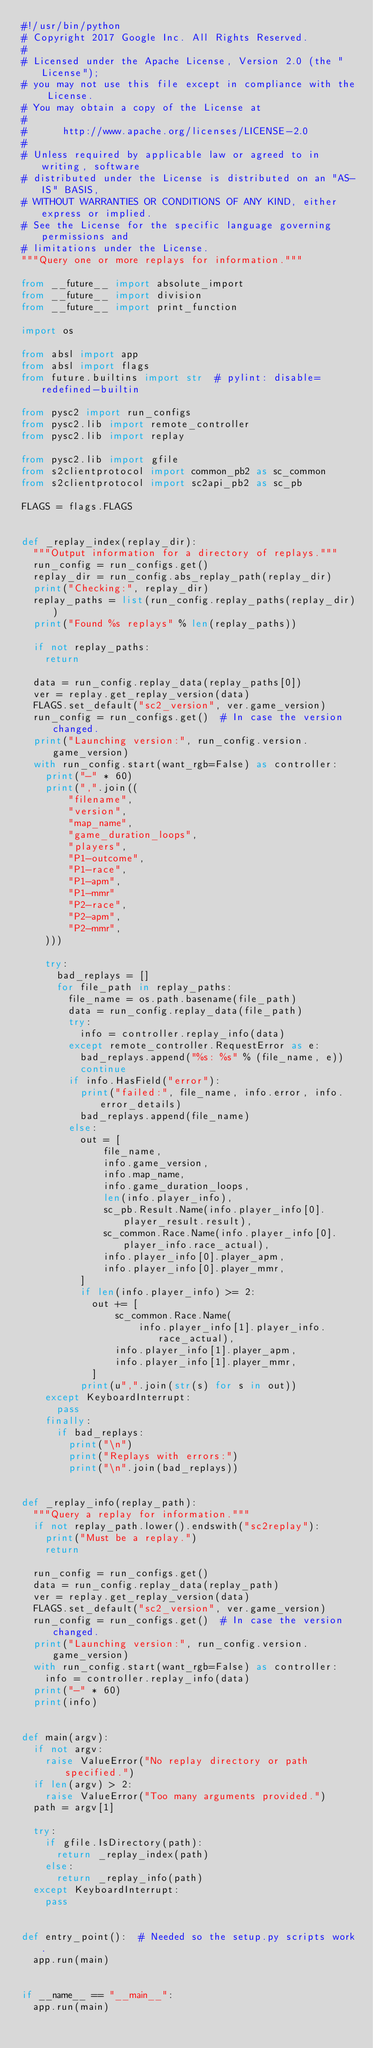<code> <loc_0><loc_0><loc_500><loc_500><_Python_>#!/usr/bin/python
# Copyright 2017 Google Inc. All Rights Reserved.
#
# Licensed under the Apache License, Version 2.0 (the "License");
# you may not use this file except in compliance with the License.
# You may obtain a copy of the License at
#
#      http://www.apache.org/licenses/LICENSE-2.0
#
# Unless required by applicable law or agreed to in writing, software
# distributed under the License is distributed on an "AS-IS" BASIS,
# WITHOUT WARRANTIES OR CONDITIONS OF ANY KIND, either express or implied.
# See the License for the specific language governing permissions and
# limitations under the License.
"""Query one or more replays for information."""

from __future__ import absolute_import
from __future__ import division
from __future__ import print_function

import os

from absl import app
from absl import flags
from future.builtins import str  # pylint: disable=redefined-builtin

from pysc2 import run_configs
from pysc2.lib import remote_controller
from pysc2.lib import replay

from pysc2.lib import gfile
from s2clientprotocol import common_pb2 as sc_common
from s2clientprotocol import sc2api_pb2 as sc_pb

FLAGS = flags.FLAGS


def _replay_index(replay_dir):
  """Output information for a directory of replays."""
  run_config = run_configs.get()
  replay_dir = run_config.abs_replay_path(replay_dir)
  print("Checking:", replay_dir)
  replay_paths = list(run_config.replay_paths(replay_dir))
  print("Found %s replays" % len(replay_paths))

  if not replay_paths:
    return

  data = run_config.replay_data(replay_paths[0])
  ver = replay.get_replay_version(data)
  FLAGS.set_default("sc2_version", ver.game_version)
  run_config = run_configs.get()  # In case the version changed.
  print("Launching version:", run_config.version.game_version)
  with run_config.start(want_rgb=False) as controller:
    print("-" * 60)
    print(",".join((
        "filename",
        "version",
        "map_name",
        "game_duration_loops",
        "players",
        "P1-outcome",
        "P1-race",
        "P1-apm",
        "P1-mmr"
        "P2-race",
        "P2-apm",
        "P2-mmr",
    )))

    try:
      bad_replays = []
      for file_path in replay_paths:
        file_name = os.path.basename(file_path)
        data = run_config.replay_data(file_path)
        try:
          info = controller.replay_info(data)
        except remote_controller.RequestError as e:
          bad_replays.append("%s: %s" % (file_name, e))
          continue
        if info.HasField("error"):
          print("failed:", file_name, info.error, info.error_details)
          bad_replays.append(file_name)
        else:
          out = [
              file_name,
              info.game_version,
              info.map_name,
              info.game_duration_loops,
              len(info.player_info),
              sc_pb.Result.Name(info.player_info[0].player_result.result),
              sc_common.Race.Name(info.player_info[0].player_info.race_actual),
              info.player_info[0].player_apm,
              info.player_info[0].player_mmr,
          ]
          if len(info.player_info) >= 2:
            out += [
                sc_common.Race.Name(
                    info.player_info[1].player_info.race_actual),
                info.player_info[1].player_apm,
                info.player_info[1].player_mmr,
            ]
          print(u",".join(str(s) for s in out))
    except KeyboardInterrupt:
      pass
    finally:
      if bad_replays:
        print("\n")
        print("Replays with errors:")
        print("\n".join(bad_replays))


def _replay_info(replay_path):
  """Query a replay for information."""
  if not replay_path.lower().endswith("sc2replay"):
    print("Must be a replay.")
    return

  run_config = run_configs.get()
  data = run_config.replay_data(replay_path)
  ver = replay.get_replay_version(data)
  FLAGS.set_default("sc2_version", ver.game_version)
  run_config = run_configs.get()  # In case the version changed.
  print("Launching version:", run_config.version.game_version)
  with run_config.start(want_rgb=False) as controller:
    info = controller.replay_info(data)
  print("-" * 60)
  print(info)


def main(argv):
  if not argv:
    raise ValueError("No replay directory or path specified.")
  if len(argv) > 2:
    raise ValueError("Too many arguments provided.")
  path = argv[1]

  try:
    if gfile.IsDirectory(path):
      return _replay_index(path)
    else:
      return _replay_info(path)
  except KeyboardInterrupt:
    pass


def entry_point():  # Needed so the setup.py scripts work.
  app.run(main)


if __name__ == "__main__":
  app.run(main)
</code> 